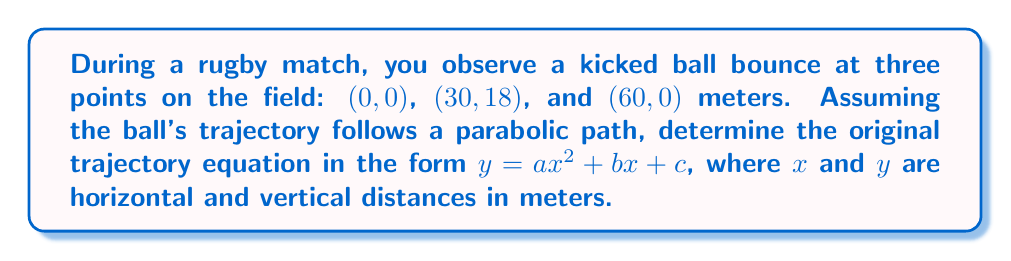What is the answer to this math problem? Let's approach this step-by-step:

1) The general form of a parabola is $y = ax^2 + bx + c$, where $a$, $b$, and $c$ are constants we need to determine.

2) We have three points that the parabola passes through:
   (0, 0), (30, 18), and (60, 0)

3) Let's substitute these points into the general equation:

   For (0, 0):   $0 = a(0)^2 + b(0) + c$, which simplifies to $c = 0$

   For (30, 18): $18 = a(30)^2 + b(30) + 0$
   
   For (60, 0):  $0 = a(60)^2 + b(60) + 0$

4) From the first equation, we know $c = 0$. Let's simplify the other two:

   $18 = 900a + 30b$  (Equation 1)
   $0 = 3600a + 60b$  (Equation 2)

5) Divide Equation 2 by 60:

   $0 = 60a + b$  (Equation 3)

6) Solve Equation 3 for $b$:

   $b = -60a$

7) Substitute this into Equation 1:

   $18 = 900a + 30(-60a)$
   $18 = 900a - 1800a$
   $18 = -900a$
   $a = -1/50 = -0.02$

8) Now we can find $b$:

   $b = -60(-0.02) = 1.2$

9) We already know $c = 0$

Therefore, the equation of the trajectory is:

$y = -0.02x^2 + 1.2x + 0$

Which simplifies to:

$y = -0.02x^2 + 1.2x$
Answer: $y = -0.02x^2 + 1.2x$ 